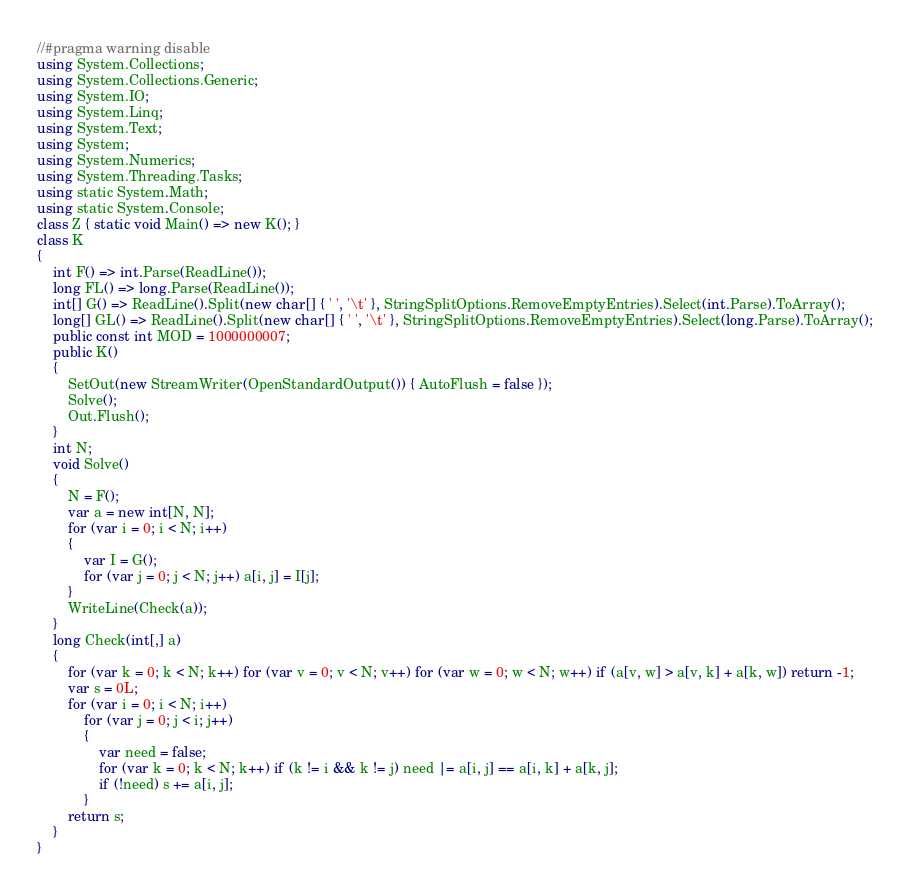<code> <loc_0><loc_0><loc_500><loc_500><_C#_>//#pragma warning disable
using System.Collections;
using System.Collections.Generic;
using System.IO;
using System.Linq;
using System.Text;
using System;
using System.Numerics;
using System.Threading.Tasks;
using static System.Math;
using static System.Console;
class Z { static void Main() => new K(); }
class K
{
	int F() => int.Parse(ReadLine());
	long FL() => long.Parse(ReadLine());
	int[] G() => ReadLine().Split(new char[] { ' ', '\t' }, StringSplitOptions.RemoveEmptyEntries).Select(int.Parse).ToArray();
	long[] GL() => ReadLine().Split(new char[] { ' ', '\t' }, StringSplitOptions.RemoveEmptyEntries).Select(long.Parse).ToArray();
	public const int MOD = 1000000007;
	public K()
	{
		SetOut(new StreamWriter(OpenStandardOutput()) { AutoFlush = false });
		Solve();
		Out.Flush();
	}
	int N;
	void Solve()
	{
		N = F();
		var a = new int[N, N];
		for (var i = 0; i < N; i++)
		{
			var I = G();
			for (var j = 0; j < N; j++) a[i, j] = I[j];
		}
		WriteLine(Check(a));
	}
	long Check(int[,] a)
	{
		for (var k = 0; k < N; k++) for (var v = 0; v < N; v++) for (var w = 0; w < N; w++) if (a[v, w] > a[v, k] + a[k, w]) return -1;
		var s = 0L;
		for (var i = 0; i < N; i++)
			for (var j = 0; j < i; j++)
			{
				var need = false;
				for (var k = 0; k < N; k++) if (k != i && k != j) need |= a[i, j] == a[i, k] + a[k, j];
				if (!need) s += a[i, j];
			}
		return s;
	}
}
</code> 